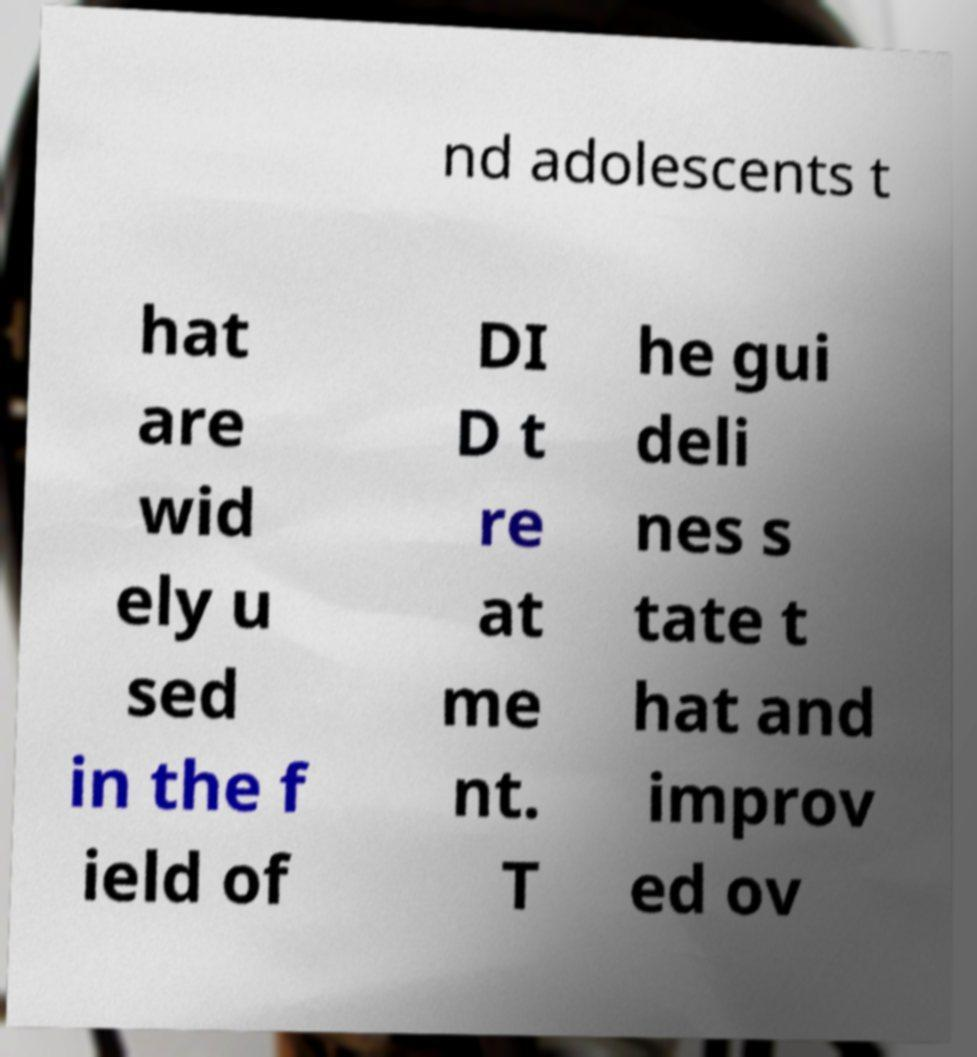I need the written content from this picture converted into text. Can you do that? nd adolescents t hat are wid ely u sed in the f ield of DI D t re at me nt. T he gui deli nes s tate t hat and improv ed ov 